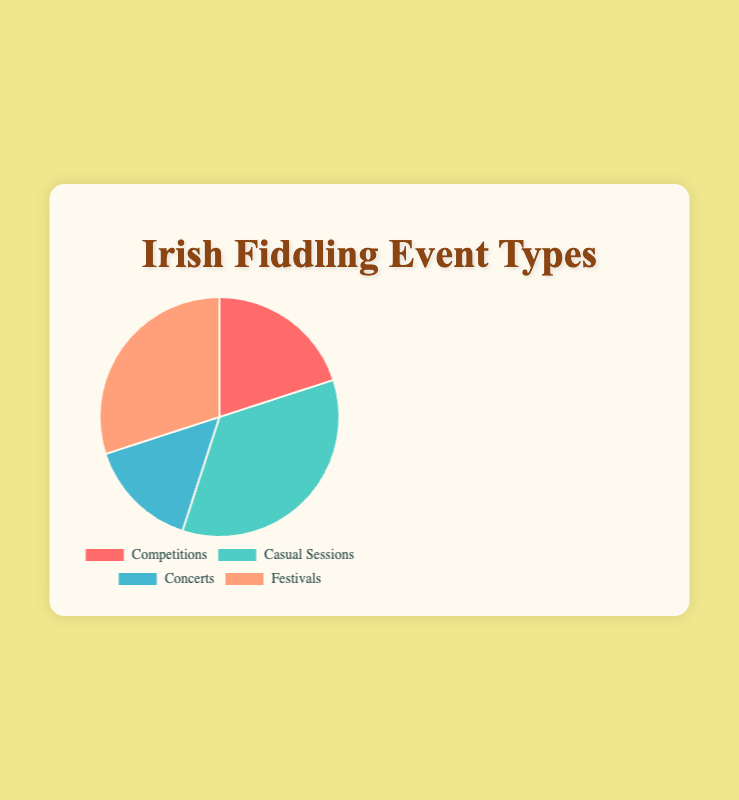What percentage of events attended are casual sessions? Refer to the pie chart and find the label for "Casual Sessions." The percentage indicated for casual sessions is 35%.
Answer: 35% Compare the attendance between competitions and concerts. Which type has a higher percentage? Look at the pie chart and identify the segments for "Competitions" and "Concerts." Competitions have a percentage of 20%, while concerts have 15%.
Answer: Competitions What is the combined percentage of competitions and festivals? Find the percentages for "Competitions" and "Festivals" in the chart. Competitions are 20% and festivals are 30%. Add these values together: 20% + 30% = 50%.
Answer: 50% If casual sessions and festivals are combined into one category called "Non-competitive Events," what is their total percentage? Add the percentages for "Casual Sessions" and "Festivals." Casual Sessions are 35%, and Festivals are 30%. So, 35% + 30% = 65%.
Answer: 65% Which event type has the smallest attendance percentage and what is that percentage? Look at the pie chart and compare the percentages for all event types. "Concerts" has the smallest percentage at 15%.
Answer: Concerts, 15% If the percentage of competitions increased by 10%, what would be the new percentage? The current percentage for competitions is 20%. Add 10% to this value: 20% + 10% = 30%.
Answer: 30% Are there more people attending festivals or casual sessions? Look at the percentages in the pie chart. Festivals have 30% while casual sessions have 35%. Therefore, more people attend casual sessions.
Answer: Casual Sessions What is the percentage difference between concerts and the most attended event type? Identify the most attended event type (Casual Sessions at 35%) and the percentage for concerts (15%). Subtract the smaller percentage from the larger: 35% - 15% = 20%.
Answer: 20% What is the median percentage of the event types? Sort the percentages in ascending order: 15%, 20%, 30%, 35%. The median value is the average of the two middle numbers: (20% + 30%) / 2 = 25%.
Answer: 25% What is the difference in percentage between the least and most attended event types? Identify the least attended event type (Concerts at 15%) and the most attended event type (Casual Sessions at 35%). Subtract the smaller percentage from the larger: 35% - 15% = 20%.
Answer: 20% 